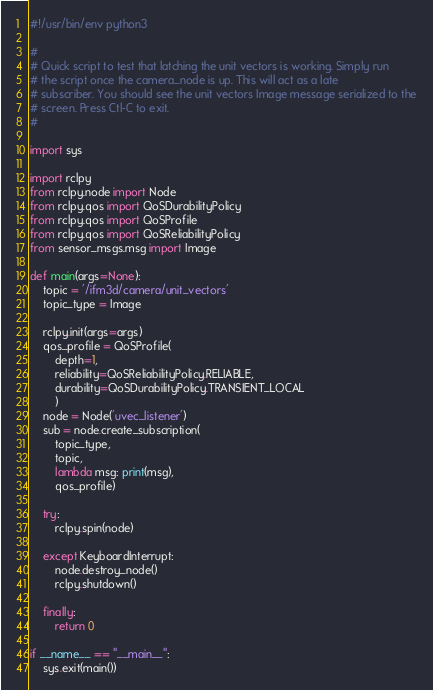<code> <loc_0><loc_0><loc_500><loc_500><_Python_>#!/usr/bin/env python3

#
# Quick script to test that latching the unit vectors is working. Simply run
# the script once the camera_node is up. This will act as a late
# subscriber. You should see the unit vectors Image message serialized to the
# screen. Press Ctl-C to exit.
#

import sys

import rclpy
from rclpy.node import Node
from rclpy.qos import QoSDurabilityPolicy
from rclpy.qos import QoSProfile
from rclpy.qos import QoSReliabilityPolicy
from sensor_msgs.msg import Image

def main(args=None):
    topic = '/ifm3d/camera/unit_vectors'
    topic_type = Image

    rclpy.init(args=args)
    qos_profile = QoSProfile(
        depth=1,
        reliability=QoSReliabilityPolicy.RELIABLE,
        durability=QoSDurabilityPolicy.TRANSIENT_LOCAL
        )
    node = Node('uvec_listener')
    sub = node.create_subscription(
        topic_type,
        topic,
        lambda msg: print(msg),
        qos_profile)

    try:
        rclpy.spin(node)

    except KeyboardInterrupt:
        node.destroy_node()
        rclpy.shutdown()

    finally:
        return 0

if __name__ == "__main__":
    sys.exit(main())
</code> 